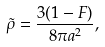<formula> <loc_0><loc_0><loc_500><loc_500>\tilde { \rho } = \frac { 3 ( 1 - F ) } { 8 \pi a ^ { 2 } } ,</formula> 